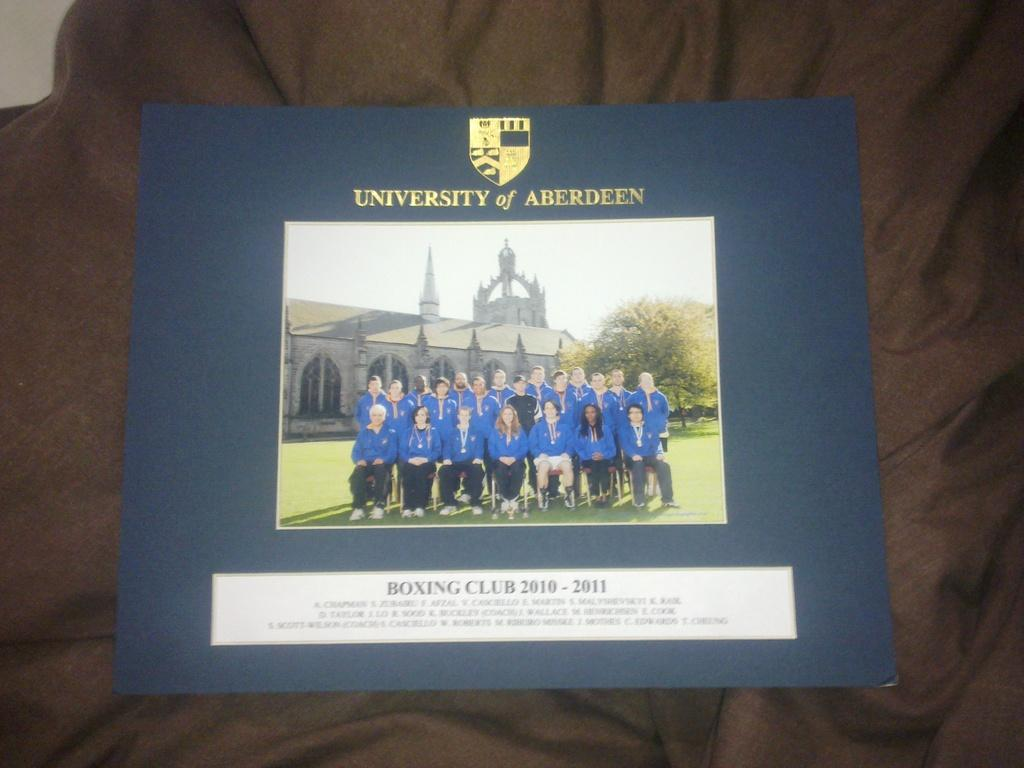<image>
Summarize the visual content of the image. A picture of the university of aberdeens' Boxing club. 